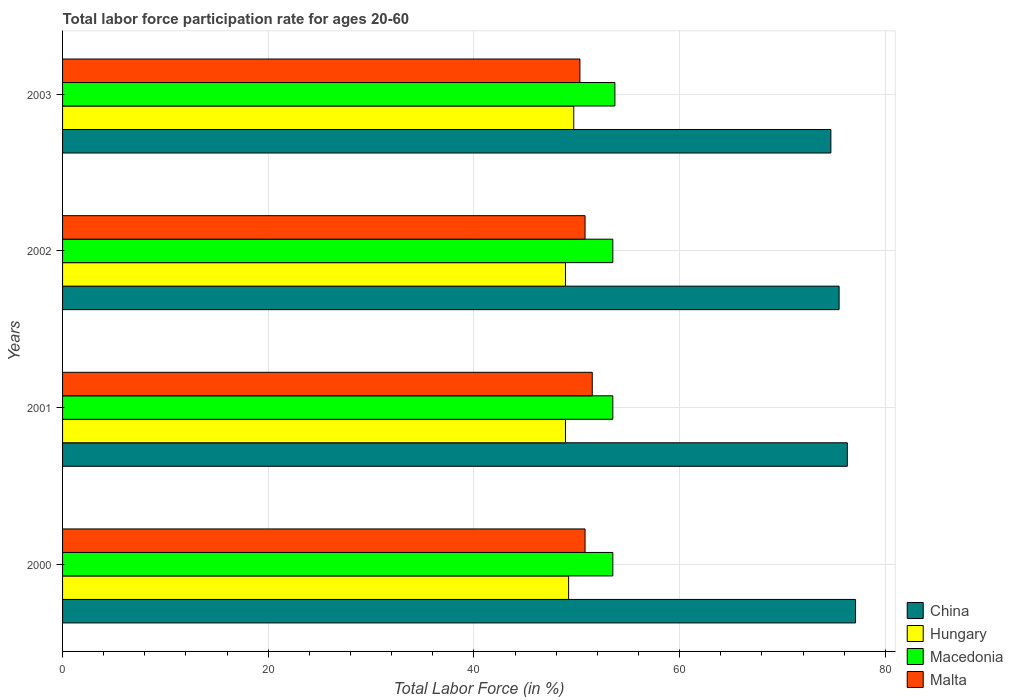How many different coloured bars are there?
Make the answer very short. 4. How many groups of bars are there?
Make the answer very short. 4. Are the number of bars per tick equal to the number of legend labels?
Provide a succinct answer. Yes. Are the number of bars on each tick of the Y-axis equal?
Provide a succinct answer. Yes. How many bars are there on the 4th tick from the top?
Ensure brevity in your answer.  4. In how many cases, is the number of bars for a given year not equal to the number of legend labels?
Provide a succinct answer. 0. What is the labor force participation rate in Malta in 2002?
Your answer should be compact. 50.8. Across all years, what is the maximum labor force participation rate in Hungary?
Your response must be concise. 49.7. Across all years, what is the minimum labor force participation rate in China?
Make the answer very short. 74.7. In which year was the labor force participation rate in Malta maximum?
Offer a very short reply. 2001. What is the total labor force participation rate in Macedonia in the graph?
Give a very brief answer. 214.2. What is the difference between the labor force participation rate in Macedonia in 2000 and that in 2003?
Your response must be concise. -0.2. What is the average labor force participation rate in Macedonia per year?
Your answer should be compact. 53.55. In the year 2001, what is the difference between the labor force participation rate in Malta and labor force participation rate in Macedonia?
Your answer should be compact. -2. In how many years, is the labor force participation rate in Macedonia greater than 8 %?
Keep it short and to the point. 4. What is the ratio of the labor force participation rate in Hungary in 2001 to that in 2003?
Keep it short and to the point. 0.98. Is the labor force participation rate in Macedonia in 2000 less than that in 2002?
Offer a very short reply. No. Is the difference between the labor force participation rate in Malta in 2000 and 2003 greater than the difference between the labor force participation rate in Macedonia in 2000 and 2003?
Give a very brief answer. Yes. What is the difference between the highest and the lowest labor force participation rate in China?
Provide a succinct answer. 2.4. In how many years, is the labor force participation rate in China greater than the average labor force participation rate in China taken over all years?
Ensure brevity in your answer.  2. Is it the case that in every year, the sum of the labor force participation rate in Hungary and labor force participation rate in Macedonia is greater than the sum of labor force participation rate in Malta and labor force participation rate in China?
Provide a short and direct response. No. What does the 3rd bar from the top in 2000 represents?
Provide a succinct answer. Hungary. Is it the case that in every year, the sum of the labor force participation rate in China and labor force participation rate in Macedonia is greater than the labor force participation rate in Hungary?
Offer a terse response. Yes. How many bars are there?
Keep it short and to the point. 16. How many years are there in the graph?
Your response must be concise. 4. What is the difference between two consecutive major ticks on the X-axis?
Provide a short and direct response. 20. Does the graph contain any zero values?
Provide a succinct answer. No. Where does the legend appear in the graph?
Your answer should be very brief. Bottom right. What is the title of the graph?
Your response must be concise. Total labor force participation rate for ages 20-60. What is the label or title of the Y-axis?
Provide a succinct answer. Years. What is the Total Labor Force (in %) in China in 2000?
Offer a terse response. 77.1. What is the Total Labor Force (in %) in Hungary in 2000?
Your answer should be very brief. 49.2. What is the Total Labor Force (in %) of Macedonia in 2000?
Give a very brief answer. 53.5. What is the Total Labor Force (in %) in Malta in 2000?
Provide a short and direct response. 50.8. What is the Total Labor Force (in %) of China in 2001?
Give a very brief answer. 76.3. What is the Total Labor Force (in %) in Hungary in 2001?
Ensure brevity in your answer.  48.9. What is the Total Labor Force (in %) in Macedonia in 2001?
Provide a short and direct response. 53.5. What is the Total Labor Force (in %) of Malta in 2001?
Offer a very short reply. 51.5. What is the Total Labor Force (in %) of China in 2002?
Provide a succinct answer. 75.5. What is the Total Labor Force (in %) of Hungary in 2002?
Your response must be concise. 48.9. What is the Total Labor Force (in %) of Macedonia in 2002?
Offer a terse response. 53.5. What is the Total Labor Force (in %) in Malta in 2002?
Your response must be concise. 50.8. What is the Total Labor Force (in %) in China in 2003?
Keep it short and to the point. 74.7. What is the Total Labor Force (in %) in Hungary in 2003?
Give a very brief answer. 49.7. What is the Total Labor Force (in %) of Macedonia in 2003?
Your response must be concise. 53.7. What is the Total Labor Force (in %) of Malta in 2003?
Keep it short and to the point. 50.3. Across all years, what is the maximum Total Labor Force (in %) of China?
Offer a terse response. 77.1. Across all years, what is the maximum Total Labor Force (in %) in Hungary?
Make the answer very short. 49.7. Across all years, what is the maximum Total Labor Force (in %) of Macedonia?
Offer a terse response. 53.7. Across all years, what is the maximum Total Labor Force (in %) of Malta?
Ensure brevity in your answer.  51.5. Across all years, what is the minimum Total Labor Force (in %) of China?
Offer a very short reply. 74.7. Across all years, what is the minimum Total Labor Force (in %) in Hungary?
Your answer should be compact. 48.9. Across all years, what is the minimum Total Labor Force (in %) in Macedonia?
Ensure brevity in your answer.  53.5. Across all years, what is the minimum Total Labor Force (in %) in Malta?
Give a very brief answer. 50.3. What is the total Total Labor Force (in %) in China in the graph?
Offer a very short reply. 303.6. What is the total Total Labor Force (in %) of Hungary in the graph?
Offer a terse response. 196.7. What is the total Total Labor Force (in %) in Macedonia in the graph?
Give a very brief answer. 214.2. What is the total Total Labor Force (in %) of Malta in the graph?
Your answer should be compact. 203.4. What is the difference between the Total Labor Force (in %) of China in 2000 and that in 2001?
Offer a very short reply. 0.8. What is the difference between the Total Labor Force (in %) of Macedonia in 2000 and that in 2001?
Keep it short and to the point. 0. What is the difference between the Total Labor Force (in %) of Malta in 2000 and that in 2003?
Your answer should be very brief. 0.5. What is the difference between the Total Labor Force (in %) of China in 2001 and that in 2002?
Make the answer very short. 0.8. What is the difference between the Total Labor Force (in %) of Hungary in 2001 and that in 2002?
Your response must be concise. 0. What is the difference between the Total Labor Force (in %) in Macedonia in 2001 and that in 2002?
Your answer should be very brief. 0. What is the difference between the Total Labor Force (in %) of Hungary in 2001 and that in 2003?
Give a very brief answer. -0.8. What is the difference between the Total Labor Force (in %) of Macedonia in 2001 and that in 2003?
Give a very brief answer. -0.2. What is the difference between the Total Labor Force (in %) of Macedonia in 2002 and that in 2003?
Make the answer very short. -0.2. What is the difference between the Total Labor Force (in %) of China in 2000 and the Total Labor Force (in %) of Hungary in 2001?
Offer a terse response. 28.2. What is the difference between the Total Labor Force (in %) of China in 2000 and the Total Labor Force (in %) of Macedonia in 2001?
Provide a succinct answer. 23.6. What is the difference between the Total Labor Force (in %) of China in 2000 and the Total Labor Force (in %) of Malta in 2001?
Your answer should be compact. 25.6. What is the difference between the Total Labor Force (in %) of Macedonia in 2000 and the Total Labor Force (in %) of Malta in 2001?
Give a very brief answer. 2. What is the difference between the Total Labor Force (in %) in China in 2000 and the Total Labor Force (in %) in Hungary in 2002?
Offer a very short reply. 28.2. What is the difference between the Total Labor Force (in %) in China in 2000 and the Total Labor Force (in %) in Macedonia in 2002?
Your answer should be compact. 23.6. What is the difference between the Total Labor Force (in %) in China in 2000 and the Total Labor Force (in %) in Malta in 2002?
Offer a terse response. 26.3. What is the difference between the Total Labor Force (in %) of China in 2000 and the Total Labor Force (in %) of Hungary in 2003?
Your response must be concise. 27.4. What is the difference between the Total Labor Force (in %) of China in 2000 and the Total Labor Force (in %) of Macedonia in 2003?
Your response must be concise. 23.4. What is the difference between the Total Labor Force (in %) of China in 2000 and the Total Labor Force (in %) of Malta in 2003?
Make the answer very short. 26.8. What is the difference between the Total Labor Force (in %) of Hungary in 2000 and the Total Labor Force (in %) of Malta in 2003?
Offer a very short reply. -1.1. What is the difference between the Total Labor Force (in %) of China in 2001 and the Total Labor Force (in %) of Hungary in 2002?
Ensure brevity in your answer.  27.4. What is the difference between the Total Labor Force (in %) of China in 2001 and the Total Labor Force (in %) of Macedonia in 2002?
Make the answer very short. 22.8. What is the difference between the Total Labor Force (in %) in China in 2001 and the Total Labor Force (in %) in Malta in 2002?
Keep it short and to the point. 25.5. What is the difference between the Total Labor Force (in %) of Hungary in 2001 and the Total Labor Force (in %) of Macedonia in 2002?
Make the answer very short. -4.6. What is the difference between the Total Labor Force (in %) in Hungary in 2001 and the Total Labor Force (in %) in Malta in 2002?
Make the answer very short. -1.9. What is the difference between the Total Labor Force (in %) of China in 2001 and the Total Labor Force (in %) of Hungary in 2003?
Your answer should be compact. 26.6. What is the difference between the Total Labor Force (in %) in China in 2001 and the Total Labor Force (in %) in Macedonia in 2003?
Make the answer very short. 22.6. What is the difference between the Total Labor Force (in %) in China in 2001 and the Total Labor Force (in %) in Malta in 2003?
Provide a succinct answer. 26. What is the difference between the Total Labor Force (in %) in Macedonia in 2001 and the Total Labor Force (in %) in Malta in 2003?
Your answer should be compact. 3.2. What is the difference between the Total Labor Force (in %) of China in 2002 and the Total Labor Force (in %) of Hungary in 2003?
Provide a short and direct response. 25.8. What is the difference between the Total Labor Force (in %) in China in 2002 and the Total Labor Force (in %) in Macedonia in 2003?
Offer a terse response. 21.8. What is the difference between the Total Labor Force (in %) in China in 2002 and the Total Labor Force (in %) in Malta in 2003?
Your answer should be very brief. 25.2. What is the difference between the Total Labor Force (in %) in Hungary in 2002 and the Total Labor Force (in %) in Macedonia in 2003?
Ensure brevity in your answer.  -4.8. What is the difference between the Total Labor Force (in %) in Hungary in 2002 and the Total Labor Force (in %) in Malta in 2003?
Offer a terse response. -1.4. What is the average Total Labor Force (in %) in China per year?
Provide a short and direct response. 75.9. What is the average Total Labor Force (in %) in Hungary per year?
Make the answer very short. 49.17. What is the average Total Labor Force (in %) of Macedonia per year?
Your answer should be compact. 53.55. What is the average Total Labor Force (in %) in Malta per year?
Offer a very short reply. 50.85. In the year 2000, what is the difference between the Total Labor Force (in %) of China and Total Labor Force (in %) of Hungary?
Provide a short and direct response. 27.9. In the year 2000, what is the difference between the Total Labor Force (in %) in China and Total Labor Force (in %) in Macedonia?
Your response must be concise. 23.6. In the year 2000, what is the difference between the Total Labor Force (in %) in China and Total Labor Force (in %) in Malta?
Provide a succinct answer. 26.3. In the year 2000, what is the difference between the Total Labor Force (in %) in Hungary and Total Labor Force (in %) in Malta?
Offer a terse response. -1.6. In the year 2000, what is the difference between the Total Labor Force (in %) of Macedonia and Total Labor Force (in %) of Malta?
Provide a short and direct response. 2.7. In the year 2001, what is the difference between the Total Labor Force (in %) in China and Total Labor Force (in %) in Hungary?
Your answer should be compact. 27.4. In the year 2001, what is the difference between the Total Labor Force (in %) in China and Total Labor Force (in %) in Macedonia?
Provide a short and direct response. 22.8. In the year 2001, what is the difference between the Total Labor Force (in %) in China and Total Labor Force (in %) in Malta?
Keep it short and to the point. 24.8. In the year 2001, what is the difference between the Total Labor Force (in %) in Hungary and Total Labor Force (in %) in Macedonia?
Offer a very short reply. -4.6. In the year 2001, what is the difference between the Total Labor Force (in %) of Hungary and Total Labor Force (in %) of Malta?
Offer a terse response. -2.6. In the year 2002, what is the difference between the Total Labor Force (in %) in China and Total Labor Force (in %) in Hungary?
Make the answer very short. 26.6. In the year 2002, what is the difference between the Total Labor Force (in %) of China and Total Labor Force (in %) of Malta?
Offer a terse response. 24.7. In the year 2002, what is the difference between the Total Labor Force (in %) of Hungary and Total Labor Force (in %) of Malta?
Give a very brief answer. -1.9. In the year 2003, what is the difference between the Total Labor Force (in %) of China and Total Labor Force (in %) of Macedonia?
Your answer should be very brief. 21. In the year 2003, what is the difference between the Total Labor Force (in %) of China and Total Labor Force (in %) of Malta?
Ensure brevity in your answer.  24.4. In the year 2003, what is the difference between the Total Labor Force (in %) in Hungary and Total Labor Force (in %) in Macedonia?
Keep it short and to the point. -4. In the year 2003, what is the difference between the Total Labor Force (in %) in Macedonia and Total Labor Force (in %) in Malta?
Ensure brevity in your answer.  3.4. What is the ratio of the Total Labor Force (in %) of China in 2000 to that in 2001?
Ensure brevity in your answer.  1.01. What is the ratio of the Total Labor Force (in %) in Hungary in 2000 to that in 2001?
Your response must be concise. 1.01. What is the ratio of the Total Labor Force (in %) of Macedonia in 2000 to that in 2001?
Your response must be concise. 1. What is the ratio of the Total Labor Force (in %) of Malta in 2000 to that in 2001?
Your response must be concise. 0.99. What is the ratio of the Total Labor Force (in %) in China in 2000 to that in 2002?
Make the answer very short. 1.02. What is the ratio of the Total Labor Force (in %) of Malta in 2000 to that in 2002?
Your response must be concise. 1. What is the ratio of the Total Labor Force (in %) in China in 2000 to that in 2003?
Keep it short and to the point. 1.03. What is the ratio of the Total Labor Force (in %) in Macedonia in 2000 to that in 2003?
Provide a succinct answer. 1. What is the ratio of the Total Labor Force (in %) in Malta in 2000 to that in 2003?
Offer a terse response. 1.01. What is the ratio of the Total Labor Force (in %) of China in 2001 to that in 2002?
Your answer should be compact. 1.01. What is the ratio of the Total Labor Force (in %) in Hungary in 2001 to that in 2002?
Offer a terse response. 1. What is the ratio of the Total Labor Force (in %) in Macedonia in 2001 to that in 2002?
Ensure brevity in your answer.  1. What is the ratio of the Total Labor Force (in %) in Malta in 2001 to that in 2002?
Make the answer very short. 1.01. What is the ratio of the Total Labor Force (in %) in China in 2001 to that in 2003?
Offer a very short reply. 1.02. What is the ratio of the Total Labor Force (in %) of Hungary in 2001 to that in 2003?
Ensure brevity in your answer.  0.98. What is the ratio of the Total Labor Force (in %) of Malta in 2001 to that in 2003?
Provide a short and direct response. 1.02. What is the ratio of the Total Labor Force (in %) in China in 2002 to that in 2003?
Offer a terse response. 1.01. What is the ratio of the Total Labor Force (in %) in Hungary in 2002 to that in 2003?
Keep it short and to the point. 0.98. What is the ratio of the Total Labor Force (in %) in Malta in 2002 to that in 2003?
Your answer should be compact. 1.01. What is the difference between the highest and the second highest Total Labor Force (in %) of China?
Ensure brevity in your answer.  0.8. What is the difference between the highest and the second highest Total Labor Force (in %) of Hungary?
Offer a terse response. 0.5. What is the difference between the highest and the second highest Total Labor Force (in %) in Malta?
Your answer should be very brief. 0.7. What is the difference between the highest and the lowest Total Labor Force (in %) of China?
Provide a succinct answer. 2.4. 